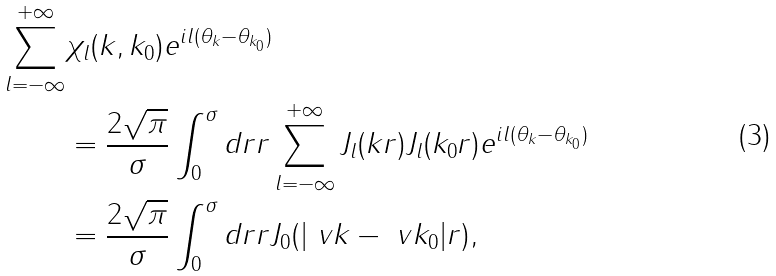Convert formula to latex. <formula><loc_0><loc_0><loc_500><loc_500>\sum _ { l = - \infty } ^ { + \infty } & \chi _ { l } ( k , k _ { 0 } ) e ^ { i l ( \theta _ { k } - \theta _ { k _ { 0 } } ) } \\ & = \frac { 2 \sqrt { \pi } } { \sigma } \int _ { 0 } ^ { \sigma } d r r \sum _ { l = - \infty } ^ { + \infty } J _ { l } ( k r ) J _ { l } ( k _ { 0 } r ) e ^ { i l ( \theta _ { k } - \theta _ { k _ { 0 } } ) } \\ & = \frac { 2 \sqrt { \pi } } { \sigma } \int _ { 0 } ^ { \sigma } d r r J _ { 0 } ( | \ v k - \ v k _ { 0 } | r ) ,</formula> 